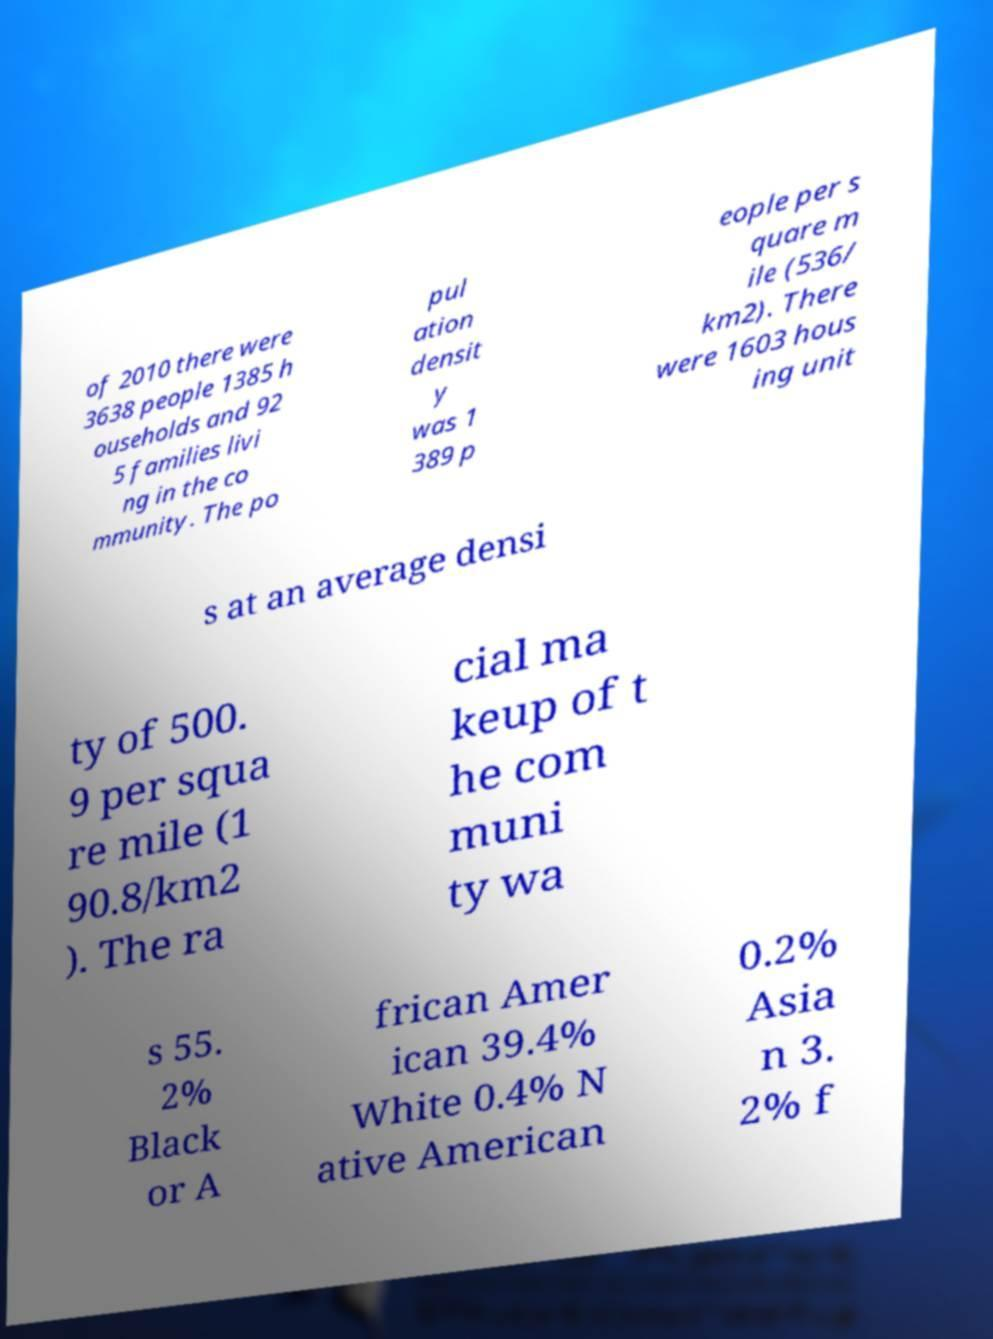I need the written content from this picture converted into text. Can you do that? of 2010 there were 3638 people 1385 h ouseholds and 92 5 families livi ng in the co mmunity. The po pul ation densit y was 1 389 p eople per s quare m ile (536/ km2). There were 1603 hous ing unit s at an average densi ty of 500. 9 per squa re mile (1 90.8/km2 ). The ra cial ma keup of t he com muni ty wa s 55. 2% Black or A frican Amer ican 39.4% White 0.4% N ative American 0.2% Asia n 3. 2% f 